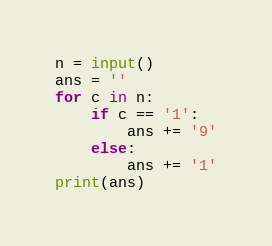<code> <loc_0><loc_0><loc_500><loc_500><_Python_>n = input()
ans = ''
for c in n:
    if c == '1':
        ans += '9'
    else:
        ans += '1'
print(ans)</code> 